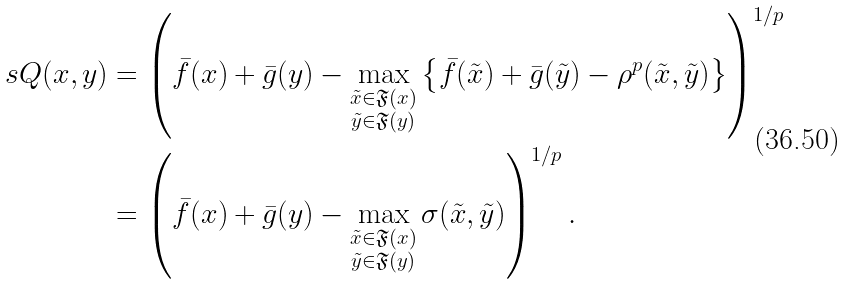<formula> <loc_0><loc_0><loc_500><loc_500>\ s Q ( x , y ) & = \left ( \bar { f } ( x ) + \bar { g } ( y ) - \max _ { \substack { \tilde { x } \in \mathfrak { F } ( x ) \\ \tilde { y } \in \mathfrak { F } ( y ) } } \left \{ \bar { f } ( \tilde { x } ) + \bar { g } ( \tilde { y } ) - \rho ^ { p } ( \tilde { x } , \tilde { y } ) \right \} \right ) ^ { 1 / p } \\ & = \left ( \bar { f } ( x ) + \bar { g } ( y ) - \max _ { \substack { \tilde { x } \in \mathfrak { F } ( x ) \\ \tilde { y } \in \mathfrak { F } ( y ) } } \sigma ( \tilde { x } , \tilde { y } ) \right ) ^ { 1 / p } .</formula> 